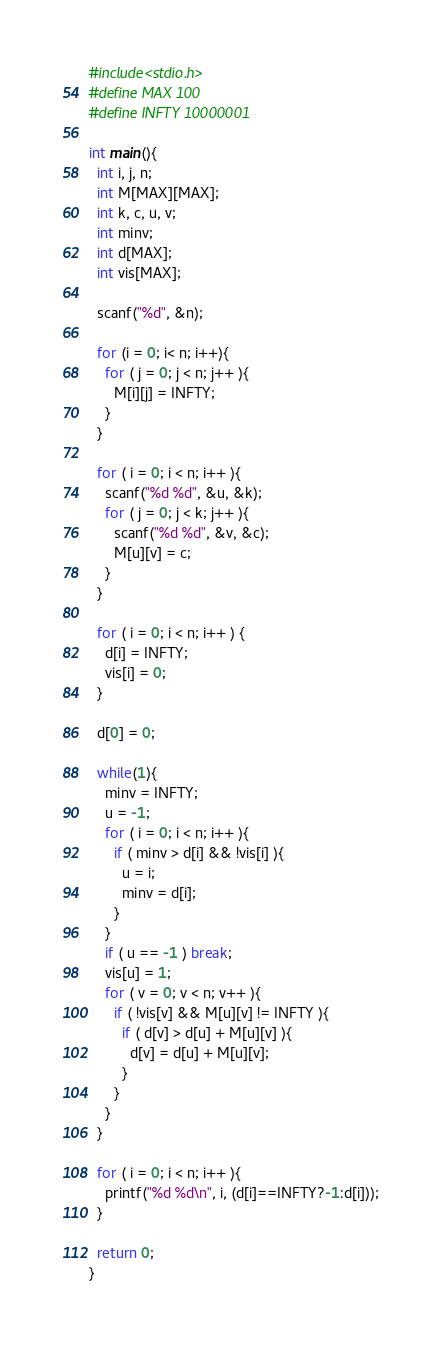<code> <loc_0><loc_0><loc_500><loc_500><_C_>#include<stdio.h>
#define MAX 100
#define INFTY 10000001

int main(){
  int i, j, n;
  int M[MAX][MAX];
  int k, c, u, v;
  int minv;
  int d[MAX];
  int vis[MAX];

  scanf("%d", &n);
  
  for (i = 0; i< n; i++){
    for ( j = 0; j < n; j++ ){
      M[i][j] = INFTY;
    }
  }

  for ( i = 0; i < n; i++ ){
    scanf("%d %d", &u, &k);
    for ( j = 0; j < k; j++ ){
      scanf("%d %d", &v, &c);
      M[u][v] = c;
    }
  }

  for ( i = 0; i < n; i++ ) {
    d[i] = INFTY;
    vis[i] = 0;
  }

  d[0] = 0;

  while(1){
    minv = INFTY;
    u = -1;
    for ( i = 0; i < n; i++ ){
      if ( minv > d[i] && !vis[i] ){
        u = i;
        minv = d[i];
      }
    }
    if ( u == -1 ) break;
    vis[u] = 1;
    for ( v = 0; v < n; v++ ){
      if ( !vis[v] && M[u][v] != INFTY ){
        if ( d[v] > d[u] + M[u][v] ){
          d[v] = d[u] + M[u][v];
        }
      }
    }
  }

  for ( i = 0; i < n; i++ ){
    printf("%d %d\n", i, (d[i]==INFTY?-1:d[i]));
  }

  return 0;
}

</code> 